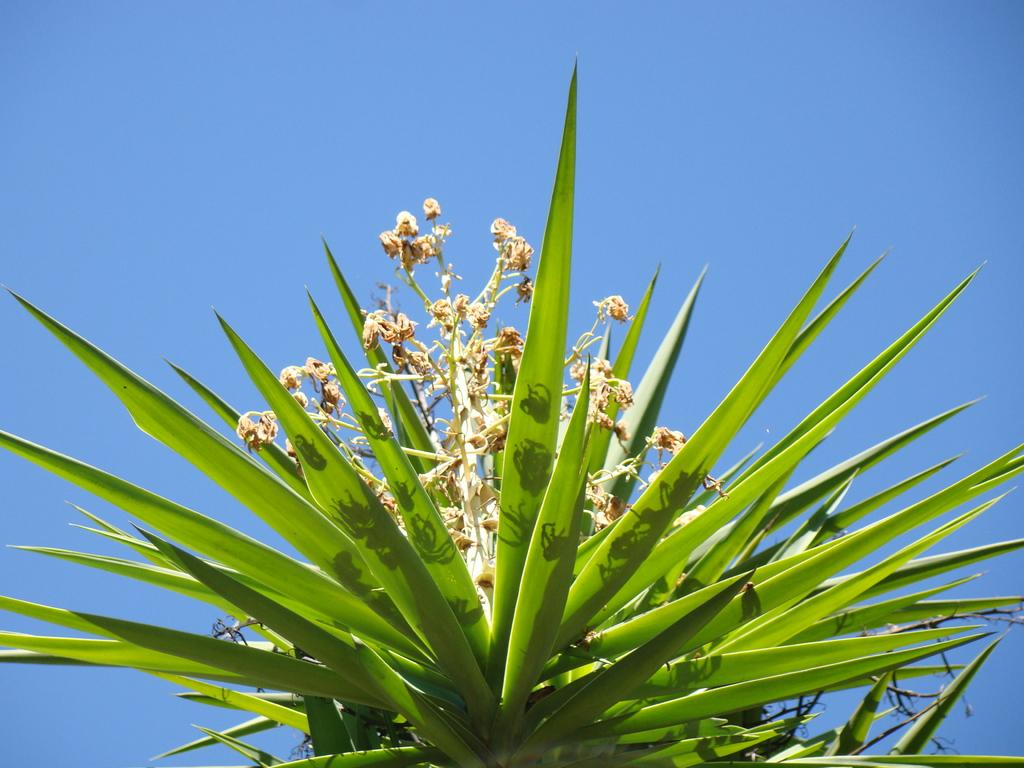What type of plant is visible in the image? There is a plant with flowers in the image. What can be seen in the background of the image? The sky is visible in the background of the image. What flavor of soap is being used to clean the train in the image? There is no train or soap present in the image; it features a plant with flowers and a visible sky in the background. 